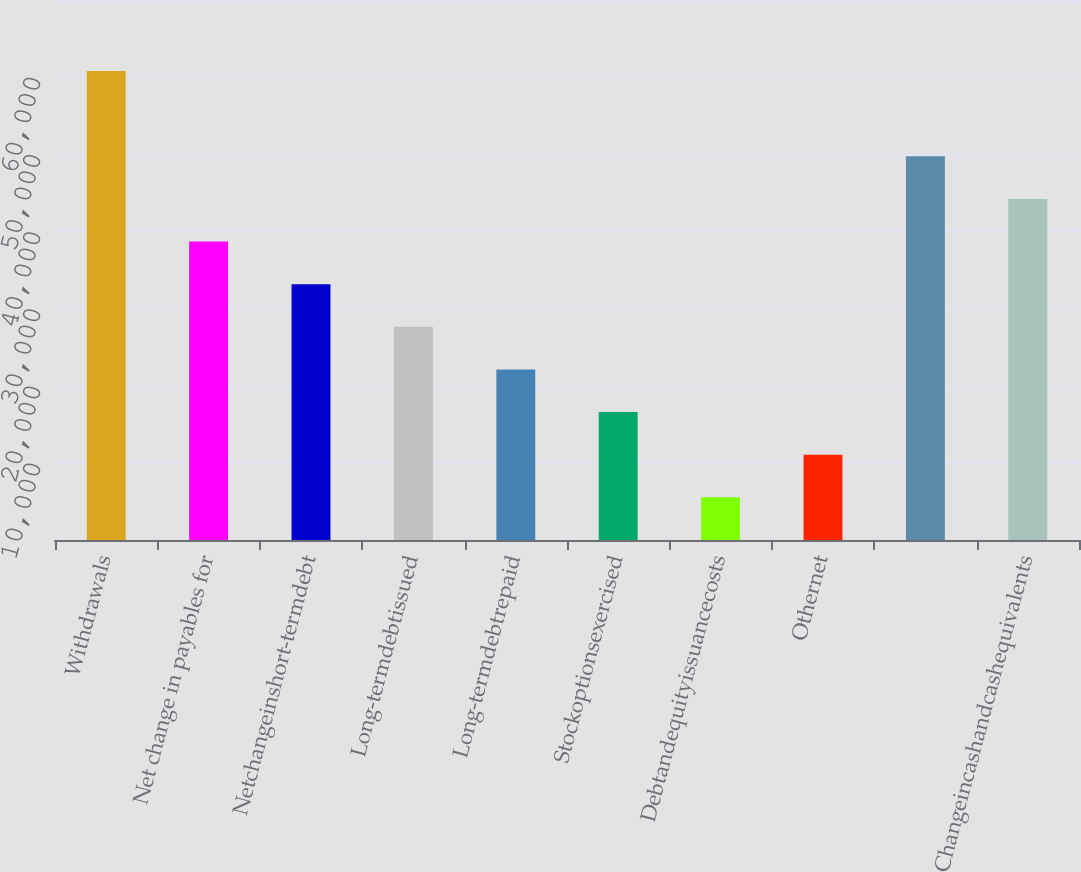<chart> <loc_0><loc_0><loc_500><loc_500><bar_chart><fcel>Withdrawals<fcel>Net change in payables for<fcel>Netchangeinshort-termdebt<fcel>Long-termdebtissued<fcel>Long-termdebtrepaid<fcel>Stockoptionsexercised<fcel>Debtandequityissuancecosts<fcel>Othernet<fcel>Unnamed: 8<fcel>Changeincashandcashequivalents<nl><fcel>60781.5<fcel>38679.5<fcel>33154<fcel>27628.5<fcel>22103<fcel>16577.5<fcel>5526.5<fcel>11052<fcel>49730.5<fcel>44205<nl></chart> 